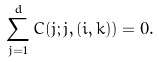Convert formula to latex. <formula><loc_0><loc_0><loc_500><loc_500>\sum _ { j = 1 } ^ { d } C ( j ; j , ( i , k ) ) = 0 .</formula> 